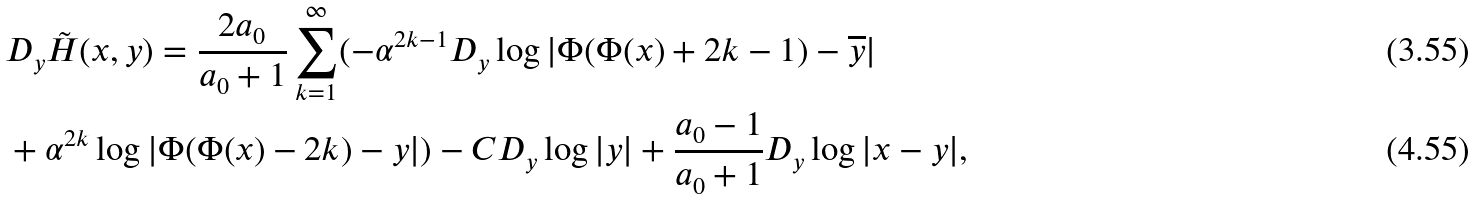<formula> <loc_0><loc_0><loc_500><loc_500>& D _ { y } \tilde { H } ( x , y ) = \frac { 2 a _ { 0 } } { a _ { 0 } + 1 } \sum _ { k = 1 } ^ { \infty } ( - \alpha ^ { 2 k - 1 } D _ { y } \log | \Phi ( \Phi ( x ) + { 2 k - 1 } ) - \overline { y } | \\ & + \alpha ^ { 2 k } \log | \Phi ( \Phi ( x ) - { 2 k } ) - y | ) - C D _ { y } \log | y | + \frac { a _ { 0 } - 1 } { a _ { 0 } + 1 } D _ { y } \log | x - y | ,</formula> 